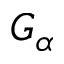Convert formula to latex. <formula><loc_0><loc_0><loc_500><loc_500>G _ { \alpha }</formula> 